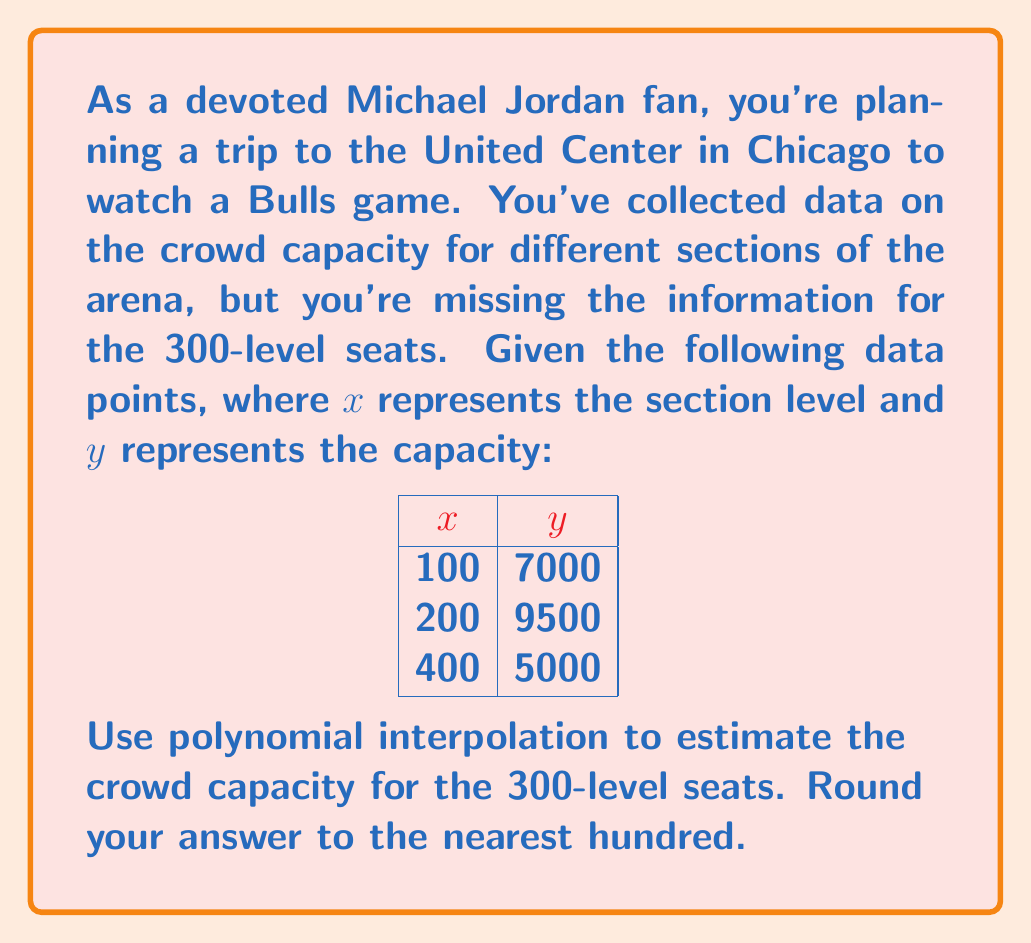Provide a solution to this math problem. To solve this problem, we'll use Lagrange polynomial interpolation:

1) The Lagrange interpolation polynomial is given by:
   $$P(x) = \sum_{i=1}^n y_i \cdot L_i(x)$$
   where $L_i(x) = \prod_{j \neq i} \frac{x - x_j}{x_i - x_j}$

2) For our data points:
   $(x_1, y_1) = (100, 7000)$
   $(x_2, y_2) = (200, 9500)$
   $(x_3, y_3) = (400, 5000)$

3) Calculate $L_1(x)$, $L_2(x)$, and $L_3(x)$:
   $$L_1(x) = \frac{(x-200)(x-400)}{(100-200)(100-400)} = \frac{(x-200)(x-400)}{-30000}$$
   $$L_2(x) = \frac{(x-100)(x-400)}{(200-100)(200-400)} = \frac{(x-100)(x-400)}{20000}$$
   $$L_3(x) = \frac{(x-100)(x-200)}{(400-100)(400-200)} = \frac{(x-100)(x-200)}{60000}$$

4) Construct the interpolation polynomial:
   $$P(x) = 7000 \cdot L_1(x) + 9500 \cdot L_2(x) + 5000 \cdot L_3(x)$$

5) Simplify and combine terms:
   $$P(x) = -\frac{7}{300}x^2 + \frac{49}{6}x + 6500$$

6) Evaluate $P(300)$ to estimate the capacity for the 300-level:
   $$P(300) = -\frac{7}{300}(300)^2 + \frac{49}{6}(300) + 6500 = 7750$$

7) Round to the nearest hundred: 7800
Answer: 7800 